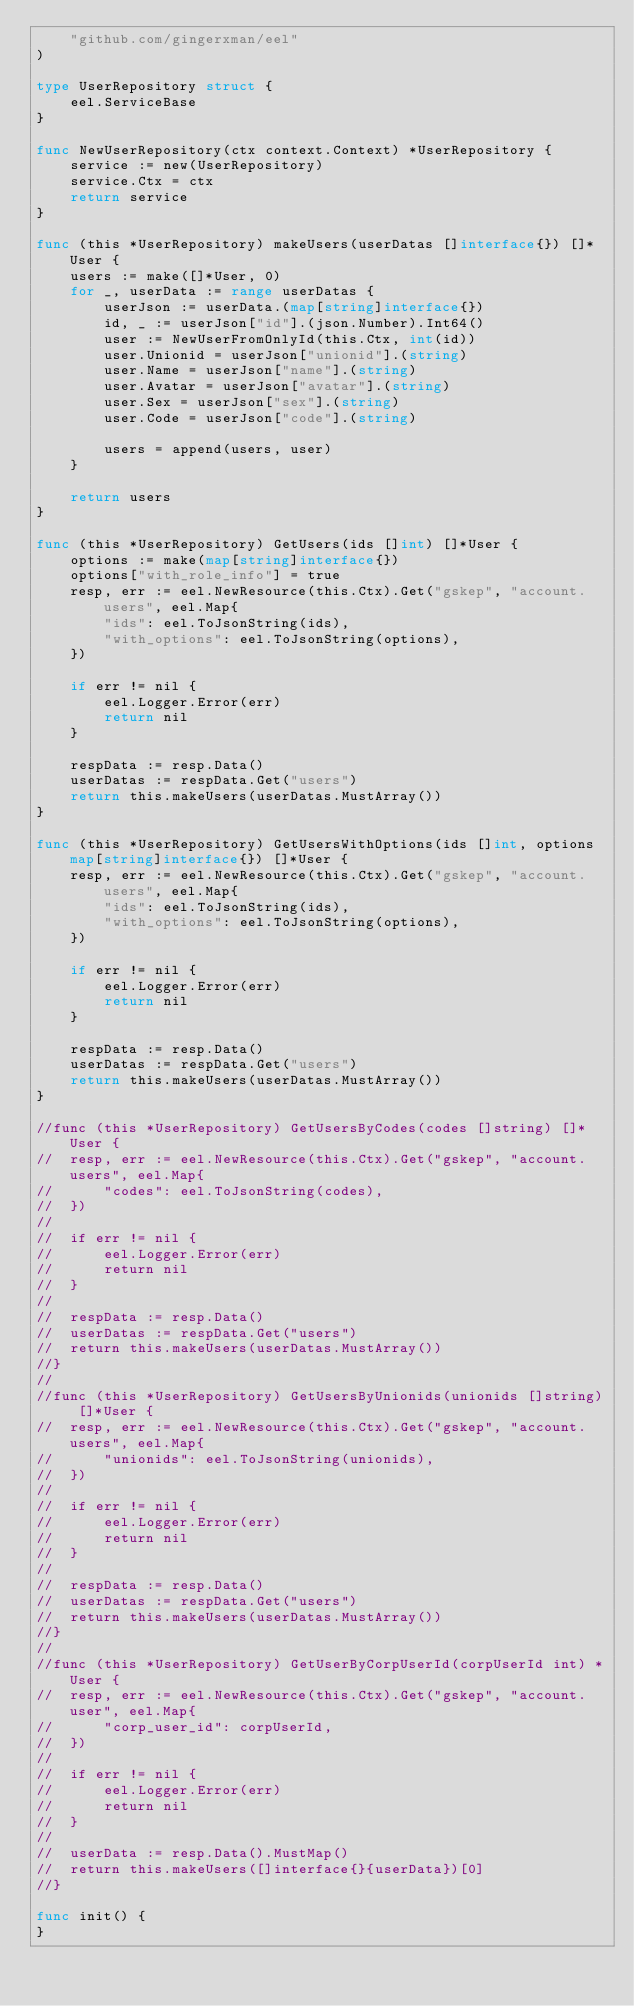Convert code to text. <code><loc_0><loc_0><loc_500><loc_500><_Go_>	"github.com/gingerxman/eel"
)

type UserRepository struct {
	eel.ServiceBase
}

func NewUserRepository(ctx context.Context) *UserRepository {
	service := new(UserRepository)
	service.Ctx = ctx
	return service
}

func (this *UserRepository) makeUsers(userDatas []interface{}) []*User {
	users := make([]*User, 0)
	for _, userData := range userDatas {
		userJson := userData.(map[string]interface{})
		id, _ := userJson["id"].(json.Number).Int64()
		user := NewUserFromOnlyId(this.Ctx, int(id))
		user.Unionid = userJson["unionid"].(string)
		user.Name = userJson["name"].(string)
		user.Avatar = userJson["avatar"].(string)
		user.Sex = userJson["sex"].(string)
		user.Code = userJson["code"].(string)
		
		users = append(users, user)
	}
	
	return users
}

func (this *UserRepository) GetUsers(ids []int) []*User {
	options := make(map[string]interface{})
	options["with_role_info"] = true
	resp, err := eel.NewResource(this.Ctx).Get("gskep", "account.users", eel.Map{
		"ids": eel.ToJsonString(ids),
		"with_options": eel.ToJsonString(options),
	})

	if err != nil {
		eel.Logger.Error(err)
		return nil
	}

	respData := resp.Data()
	userDatas := respData.Get("users")
	return this.makeUsers(userDatas.MustArray())
}

func (this *UserRepository) GetUsersWithOptions(ids []int, options map[string]interface{}) []*User {
	resp, err := eel.NewResource(this.Ctx).Get("gskep", "account.users", eel.Map{
		"ids": eel.ToJsonString(ids),
		"with_options": eel.ToJsonString(options),
	})

	if err != nil {
		eel.Logger.Error(err)
		return nil
	}

	respData := resp.Data()
	userDatas := respData.Get("users")
	return this.makeUsers(userDatas.MustArray())
}

//func (this *UserRepository) GetUsersByCodes(codes []string) []*User {
//	resp, err := eel.NewResource(this.Ctx).Get("gskep", "account.users", eel.Map{
//		"codes": eel.ToJsonString(codes),
//	})
//
//	if err != nil {
//		eel.Logger.Error(err)
//		return nil
//	}
//
//	respData := resp.Data()
//	userDatas := respData.Get("users")
//	return this.makeUsers(userDatas.MustArray())
//}
//
//func (this *UserRepository) GetUsersByUnionids(unionids []string) []*User {
//	resp, err := eel.NewResource(this.Ctx).Get("gskep", "account.users", eel.Map{
//		"unionids": eel.ToJsonString(unionids),
//	})
//
//	if err != nil {
//		eel.Logger.Error(err)
//		return nil
//	}
//
//	respData := resp.Data()
//	userDatas := respData.Get("users")
//	return this.makeUsers(userDatas.MustArray())
//}
//
//func (this *UserRepository) GetUserByCorpUserId(corpUserId int) *User {
//	resp, err := eel.NewResource(this.Ctx).Get("gskep", "account.user", eel.Map{
//		"corp_user_id": corpUserId,
//	})
//
//	if err != nil {
//		eel.Logger.Error(err)
//		return nil
//	}
//
//	userData := resp.Data().MustMap()
//	return this.makeUsers([]interface{}{userData})[0]
//}

func init() {
}
</code> 